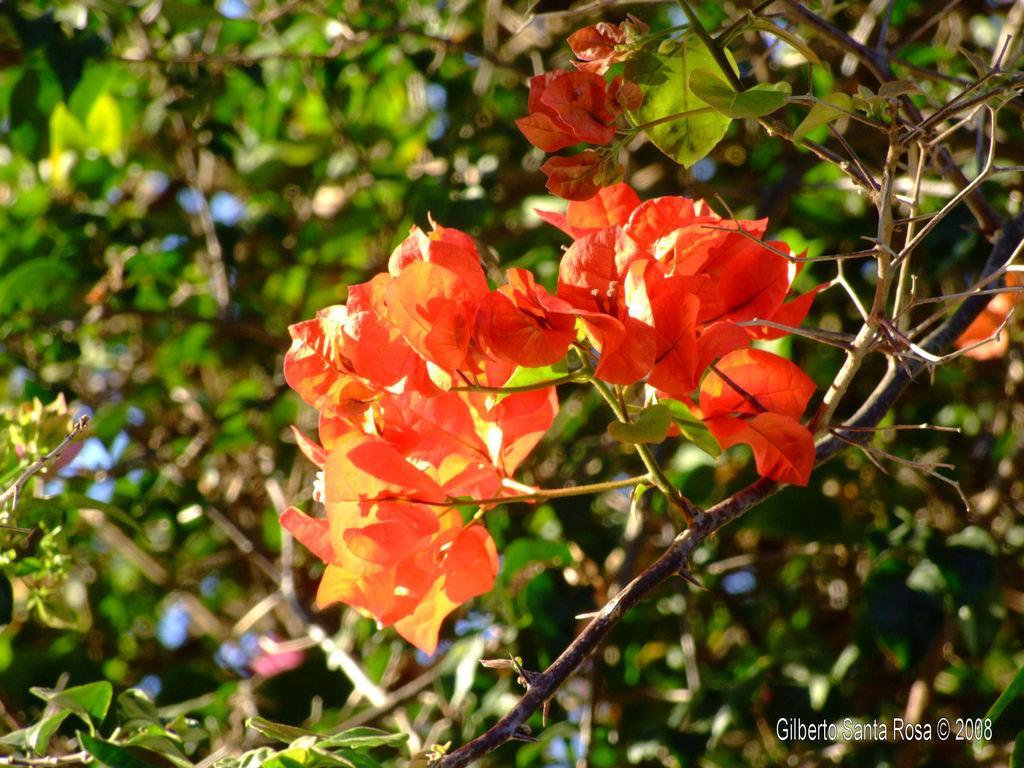Please provide a concise description of this image. In this image in the front there are flowers on the plant and the background is blurry. 